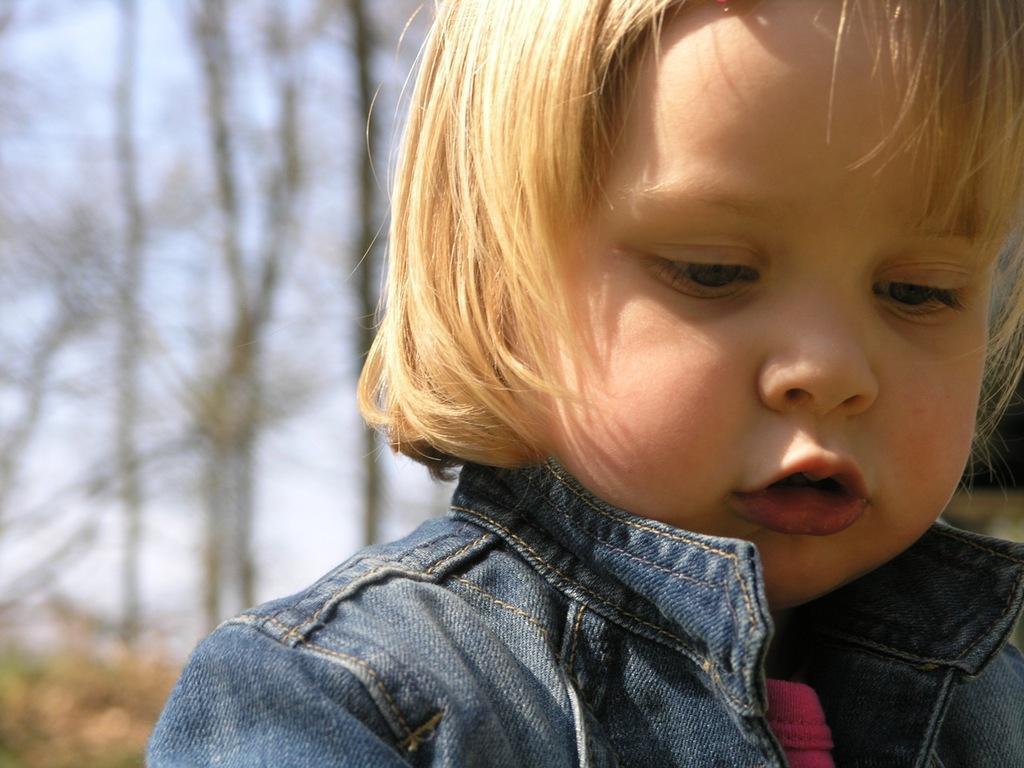Please provide a concise description of this image. In this image, I can see a small girl. She wore a jacket. In the background, these look like the trees. 